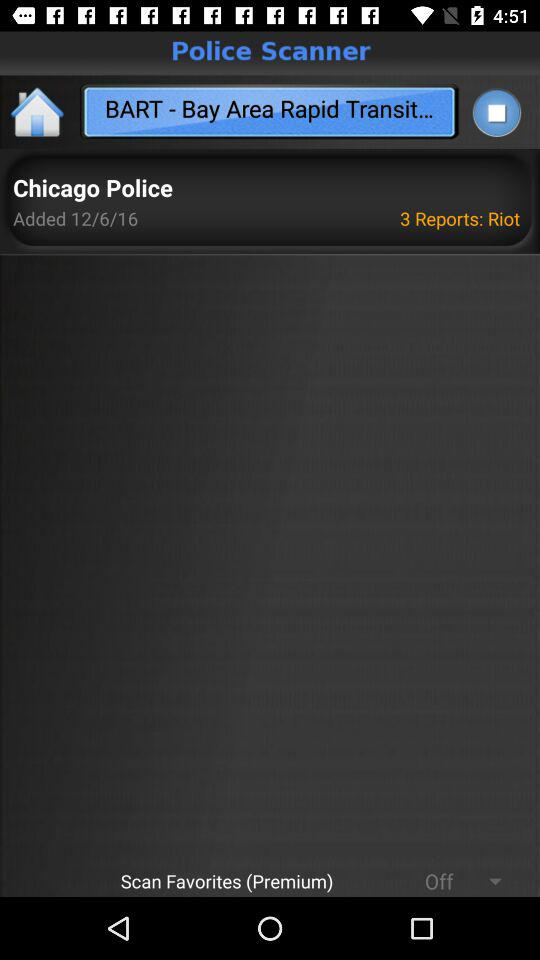Who added the reports? The reports were added by "Chicago Police". 